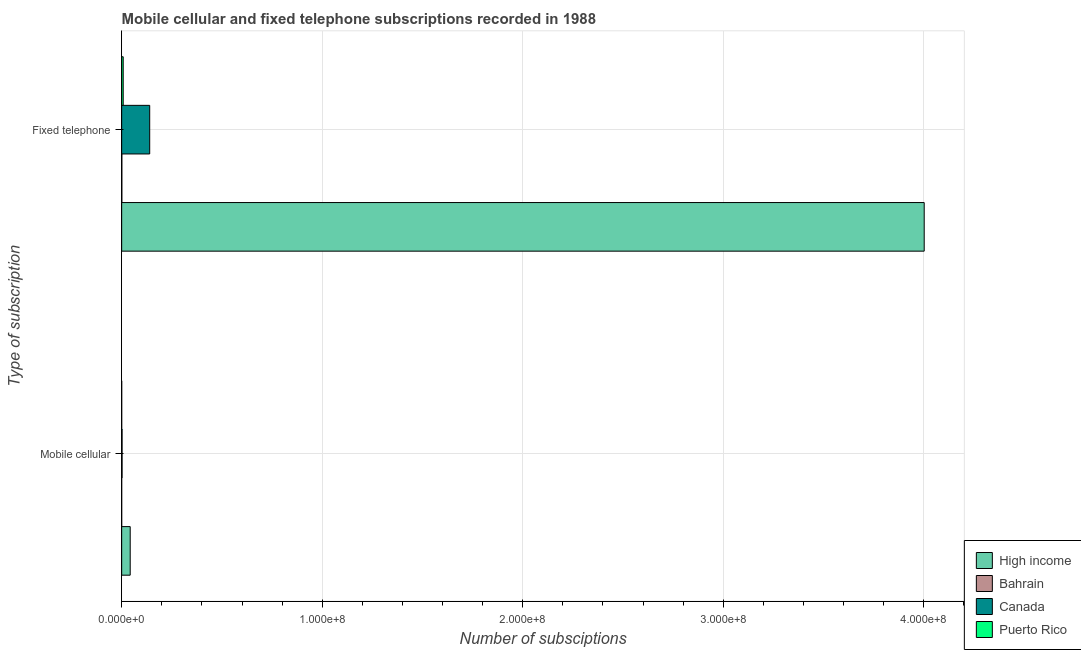How many groups of bars are there?
Offer a very short reply. 2. Are the number of bars per tick equal to the number of legend labels?
Provide a succinct answer. Yes. Are the number of bars on each tick of the Y-axis equal?
Offer a terse response. Yes. How many bars are there on the 2nd tick from the top?
Your response must be concise. 4. What is the label of the 1st group of bars from the top?
Your answer should be compact. Fixed telephone. What is the number of fixed telephone subscriptions in Puerto Rico?
Your response must be concise. 7.64e+05. Across all countries, what is the maximum number of mobile cellular subscriptions?
Your answer should be compact. 4.26e+06. Across all countries, what is the minimum number of fixed telephone subscriptions?
Offer a very short reply. 8.30e+04. In which country was the number of fixed telephone subscriptions minimum?
Offer a very short reply. Bahrain. What is the total number of fixed telephone subscriptions in the graph?
Offer a very short reply. 4.15e+08. What is the difference between the number of mobile cellular subscriptions in High income and that in Canada?
Offer a very short reply. 4.05e+06. What is the difference between the number of fixed telephone subscriptions in Puerto Rico and the number of mobile cellular subscriptions in Bahrain?
Your response must be concise. 7.61e+05. What is the average number of fixed telephone subscriptions per country?
Make the answer very short. 1.04e+08. What is the difference between the number of fixed telephone subscriptions and number of mobile cellular subscriptions in Canada?
Provide a short and direct response. 1.38e+07. What is the ratio of the number of fixed telephone subscriptions in Puerto Rico to that in Bahrain?
Offer a terse response. 9.2. What does the 3rd bar from the top in Fixed telephone represents?
Give a very brief answer. Bahrain. How many bars are there?
Provide a succinct answer. 8. How many countries are there in the graph?
Provide a succinct answer. 4. Are the values on the major ticks of X-axis written in scientific E-notation?
Offer a terse response. Yes. Where does the legend appear in the graph?
Your answer should be compact. Bottom right. How many legend labels are there?
Your response must be concise. 4. How are the legend labels stacked?
Ensure brevity in your answer.  Vertical. What is the title of the graph?
Make the answer very short. Mobile cellular and fixed telephone subscriptions recorded in 1988. Does "Burundi" appear as one of the legend labels in the graph?
Provide a short and direct response. No. What is the label or title of the X-axis?
Provide a short and direct response. Number of subsciptions. What is the label or title of the Y-axis?
Provide a succinct answer. Type of subscription. What is the Number of subsciptions in High income in Mobile cellular?
Give a very brief answer. 4.26e+06. What is the Number of subsciptions in Bahrain in Mobile cellular?
Provide a short and direct response. 2886. What is the Number of subsciptions of Canada in Mobile cellular?
Your answer should be compact. 2.03e+05. What is the Number of subsciptions in Puerto Rico in Mobile cellular?
Your response must be concise. 8700. What is the Number of subsciptions in High income in Fixed telephone?
Make the answer very short. 4.00e+08. What is the Number of subsciptions in Bahrain in Fixed telephone?
Your answer should be compact. 8.30e+04. What is the Number of subsciptions of Canada in Fixed telephone?
Provide a succinct answer. 1.40e+07. What is the Number of subsciptions in Puerto Rico in Fixed telephone?
Your response must be concise. 7.64e+05. Across all Type of subscription, what is the maximum Number of subsciptions in High income?
Give a very brief answer. 4.00e+08. Across all Type of subscription, what is the maximum Number of subsciptions of Bahrain?
Offer a terse response. 8.30e+04. Across all Type of subscription, what is the maximum Number of subsciptions of Canada?
Ensure brevity in your answer.  1.40e+07. Across all Type of subscription, what is the maximum Number of subsciptions of Puerto Rico?
Offer a terse response. 7.64e+05. Across all Type of subscription, what is the minimum Number of subsciptions of High income?
Offer a terse response. 4.26e+06. Across all Type of subscription, what is the minimum Number of subsciptions in Bahrain?
Offer a very short reply. 2886. Across all Type of subscription, what is the minimum Number of subsciptions of Canada?
Your response must be concise. 2.03e+05. Across all Type of subscription, what is the minimum Number of subsciptions in Puerto Rico?
Give a very brief answer. 8700. What is the total Number of subsciptions in High income in the graph?
Your response must be concise. 4.04e+08. What is the total Number of subsciptions in Bahrain in the graph?
Offer a terse response. 8.59e+04. What is the total Number of subsciptions in Canada in the graph?
Give a very brief answer. 1.42e+07. What is the total Number of subsciptions of Puerto Rico in the graph?
Keep it short and to the point. 7.72e+05. What is the difference between the Number of subsciptions in High income in Mobile cellular and that in Fixed telephone?
Give a very brief answer. -3.96e+08. What is the difference between the Number of subsciptions in Bahrain in Mobile cellular and that in Fixed telephone?
Your answer should be compact. -8.01e+04. What is the difference between the Number of subsciptions in Canada in Mobile cellular and that in Fixed telephone?
Provide a short and direct response. -1.38e+07. What is the difference between the Number of subsciptions of Puerto Rico in Mobile cellular and that in Fixed telephone?
Offer a very short reply. -7.55e+05. What is the difference between the Number of subsciptions in High income in Mobile cellular and the Number of subsciptions in Bahrain in Fixed telephone?
Offer a terse response. 4.17e+06. What is the difference between the Number of subsciptions in High income in Mobile cellular and the Number of subsciptions in Canada in Fixed telephone?
Your response must be concise. -9.72e+06. What is the difference between the Number of subsciptions of High income in Mobile cellular and the Number of subsciptions of Puerto Rico in Fixed telephone?
Make the answer very short. 3.49e+06. What is the difference between the Number of subsciptions in Bahrain in Mobile cellular and the Number of subsciptions in Canada in Fixed telephone?
Provide a short and direct response. -1.40e+07. What is the difference between the Number of subsciptions in Bahrain in Mobile cellular and the Number of subsciptions in Puerto Rico in Fixed telephone?
Keep it short and to the point. -7.61e+05. What is the difference between the Number of subsciptions in Canada in Mobile cellular and the Number of subsciptions in Puerto Rico in Fixed telephone?
Provide a succinct answer. -5.61e+05. What is the average Number of subsciptions of High income per Type of subscription?
Give a very brief answer. 2.02e+08. What is the average Number of subsciptions of Bahrain per Type of subscription?
Your answer should be very brief. 4.29e+04. What is the average Number of subsciptions of Canada per Type of subscription?
Give a very brief answer. 7.09e+06. What is the average Number of subsciptions in Puerto Rico per Type of subscription?
Offer a terse response. 3.86e+05. What is the difference between the Number of subsciptions in High income and Number of subsciptions in Bahrain in Mobile cellular?
Keep it short and to the point. 4.25e+06. What is the difference between the Number of subsciptions in High income and Number of subsciptions in Canada in Mobile cellular?
Provide a short and direct response. 4.05e+06. What is the difference between the Number of subsciptions of High income and Number of subsciptions of Puerto Rico in Mobile cellular?
Provide a succinct answer. 4.25e+06. What is the difference between the Number of subsciptions of Bahrain and Number of subsciptions of Canada in Mobile cellular?
Provide a short and direct response. -2.00e+05. What is the difference between the Number of subsciptions in Bahrain and Number of subsciptions in Puerto Rico in Mobile cellular?
Make the answer very short. -5814. What is the difference between the Number of subsciptions in Canada and Number of subsciptions in Puerto Rico in Mobile cellular?
Your response must be concise. 1.94e+05. What is the difference between the Number of subsciptions in High income and Number of subsciptions in Bahrain in Fixed telephone?
Your response must be concise. 4.00e+08. What is the difference between the Number of subsciptions of High income and Number of subsciptions of Canada in Fixed telephone?
Provide a succinct answer. 3.86e+08. What is the difference between the Number of subsciptions in High income and Number of subsciptions in Puerto Rico in Fixed telephone?
Provide a short and direct response. 3.99e+08. What is the difference between the Number of subsciptions of Bahrain and Number of subsciptions of Canada in Fixed telephone?
Make the answer very short. -1.39e+07. What is the difference between the Number of subsciptions in Bahrain and Number of subsciptions in Puerto Rico in Fixed telephone?
Your response must be concise. -6.81e+05. What is the difference between the Number of subsciptions of Canada and Number of subsciptions of Puerto Rico in Fixed telephone?
Offer a terse response. 1.32e+07. What is the ratio of the Number of subsciptions of High income in Mobile cellular to that in Fixed telephone?
Your response must be concise. 0.01. What is the ratio of the Number of subsciptions of Bahrain in Mobile cellular to that in Fixed telephone?
Provide a short and direct response. 0.03. What is the ratio of the Number of subsciptions in Canada in Mobile cellular to that in Fixed telephone?
Your answer should be very brief. 0.01. What is the ratio of the Number of subsciptions in Puerto Rico in Mobile cellular to that in Fixed telephone?
Your response must be concise. 0.01. What is the difference between the highest and the second highest Number of subsciptions of High income?
Give a very brief answer. 3.96e+08. What is the difference between the highest and the second highest Number of subsciptions in Bahrain?
Offer a terse response. 8.01e+04. What is the difference between the highest and the second highest Number of subsciptions of Canada?
Provide a succinct answer. 1.38e+07. What is the difference between the highest and the second highest Number of subsciptions in Puerto Rico?
Your answer should be compact. 7.55e+05. What is the difference between the highest and the lowest Number of subsciptions in High income?
Ensure brevity in your answer.  3.96e+08. What is the difference between the highest and the lowest Number of subsciptions in Bahrain?
Offer a very short reply. 8.01e+04. What is the difference between the highest and the lowest Number of subsciptions in Canada?
Your answer should be compact. 1.38e+07. What is the difference between the highest and the lowest Number of subsciptions of Puerto Rico?
Make the answer very short. 7.55e+05. 